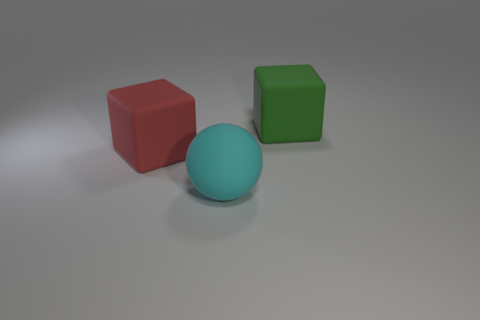How many objects are big blocks or large rubber objects?
Give a very brief answer. 3. What shape is the big rubber object that is on the left side of the green block and behind the large cyan rubber sphere?
Make the answer very short. Cube. There is a green matte object; is its shape the same as the big thing left of the cyan matte ball?
Give a very brief answer. Yes. Are there any cyan matte spheres right of the cyan sphere?
Provide a short and direct response. No. How many balls are either tiny green objects or red things?
Ensure brevity in your answer.  0. Is the shape of the large green rubber object the same as the cyan rubber object?
Provide a short and direct response. No. There is a cube left of the big cyan sphere; what size is it?
Give a very brief answer. Large. Are there any other spheres of the same color as the sphere?
Provide a short and direct response. No. There is a cyan object that is in front of the red matte block; is it the same size as the green rubber object?
Keep it short and to the point. Yes. The large rubber sphere is what color?
Your answer should be very brief. Cyan. 